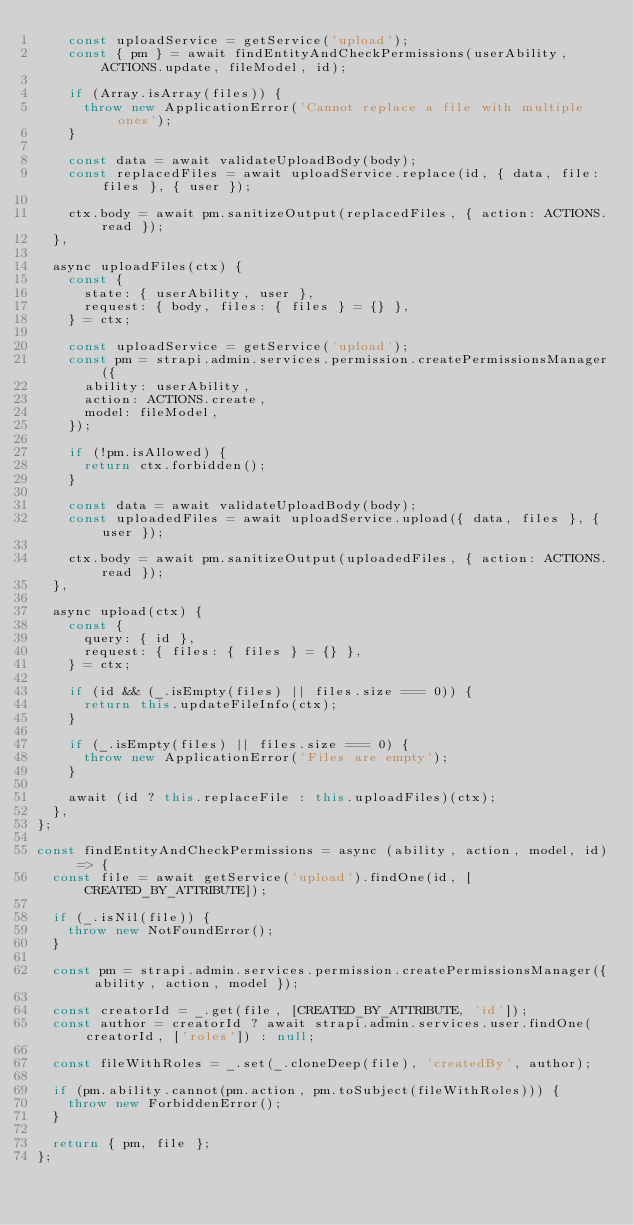<code> <loc_0><loc_0><loc_500><loc_500><_JavaScript_>    const uploadService = getService('upload');
    const { pm } = await findEntityAndCheckPermissions(userAbility, ACTIONS.update, fileModel, id);

    if (Array.isArray(files)) {
      throw new ApplicationError('Cannot replace a file with multiple ones');
    }

    const data = await validateUploadBody(body);
    const replacedFiles = await uploadService.replace(id, { data, file: files }, { user });

    ctx.body = await pm.sanitizeOutput(replacedFiles, { action: ACTIONS.read });
  },

  async uploadFiles(ctx) {
    const {
      state: { userAbility, user },
      request: { body, files: { files } = {} },
    } = ctx;

    const uploadService = getService('upload');
    const pm = strapi.admin.services.permission.createPermissionsManager({
      ability: userAbility,
      action: ACTIONS.create,
      model: fileModel,
    });

    if (!pm.isAllowed) {
      return ctx.forbidden();
    }

    const data = await validateUploadBody(body);
    const uploadedFiles = await uploadService.upload({ data, files }, { user });

    ctx.body = await pm.sanitizeOutput(uploadedFiles, { action: ACTIONS.read });
  },

  async upload(ctx) {
    const {
      query: { id },
      request: { files: { files } = {} },
    } = ctx;

    if (id && (_.isEmpty(files) || files.size === 0)) {
      return this.updateFileInfo(ctx);
    }

    if (_.isEmpty(files) || files.size === 0) {
      throw new ApplicationError('Files are empty');
    }

    await (id ? this.replaceFile : this.uploadFiles)(ctx);
  },
};

const findEntityAndCheckPermissions = async (ability, action, model, id) => {
  const file = await getService('upload').findOne(id, [CREATED_BY_ATTRIBUTE]);

  if (_.isNil(file)) {
    throw new NotFoundError();
  }

  const pm = strapi.admin.services.permission.createPermissionsManager({ ability, action, model });

  const creatorId = _.get(file, [CREATED_BY_ATTRIBUTE, 'id']);
  const author = creatorId ? await strapi.admin.services.user.findOne(creatorId, ['roles']) : null;

  const fileWithRoles = _.set(_.cloneDeep(file), 'createdBy', author);

  if (pm.ability.cannot(pm.action, pm.toSubject(fileWithRoles))) {
    throw new ForbiddenError();
  }

  return { pm, file };
};
</code> 